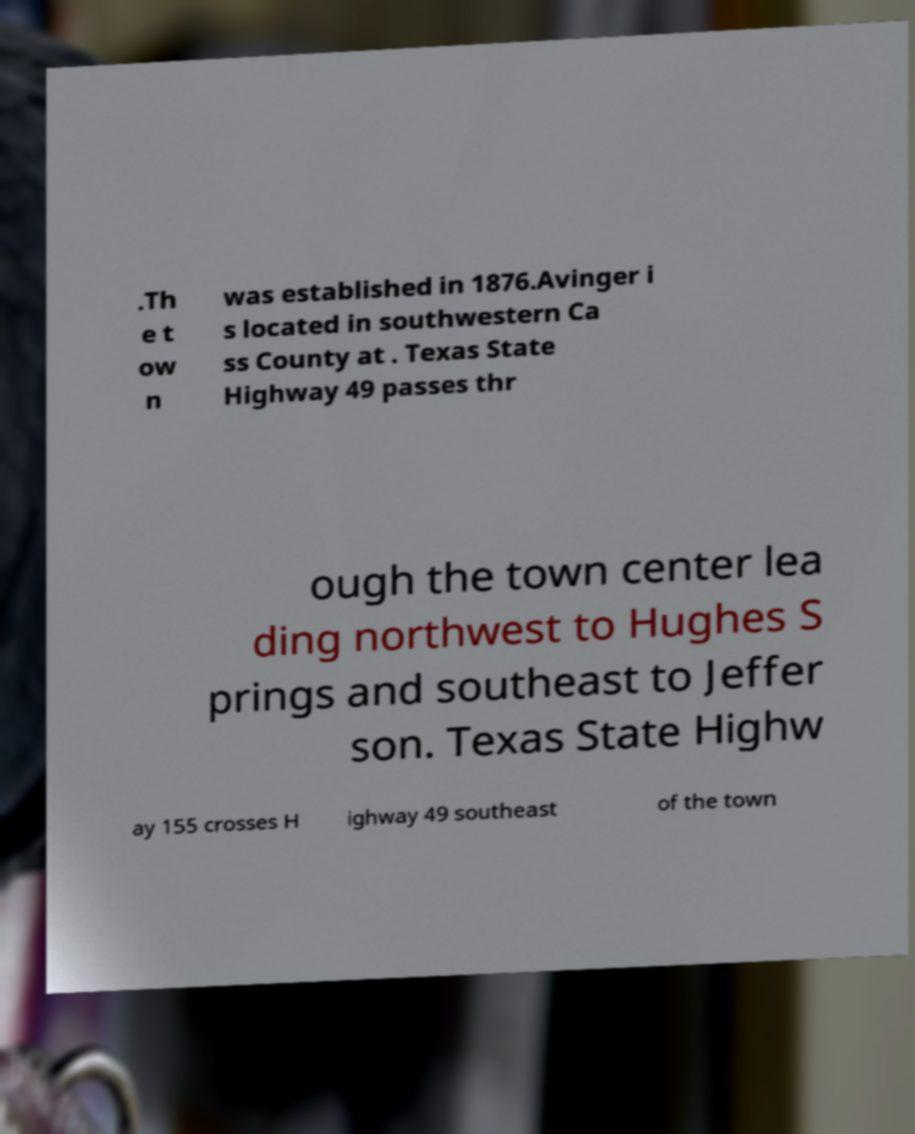Could you assist in decoding the text presented in this image and type it out clearly? .Th e t ow n was established in 1876.Avinger i s located in southwestern Ca ss County at . Texas State Highway 49 passes thr ough the town center lea ding northwest to Hughes S prings and southeast to Jeffer son. Texas State Highw ay 155 crosses H ighway 49 southeast of the town 